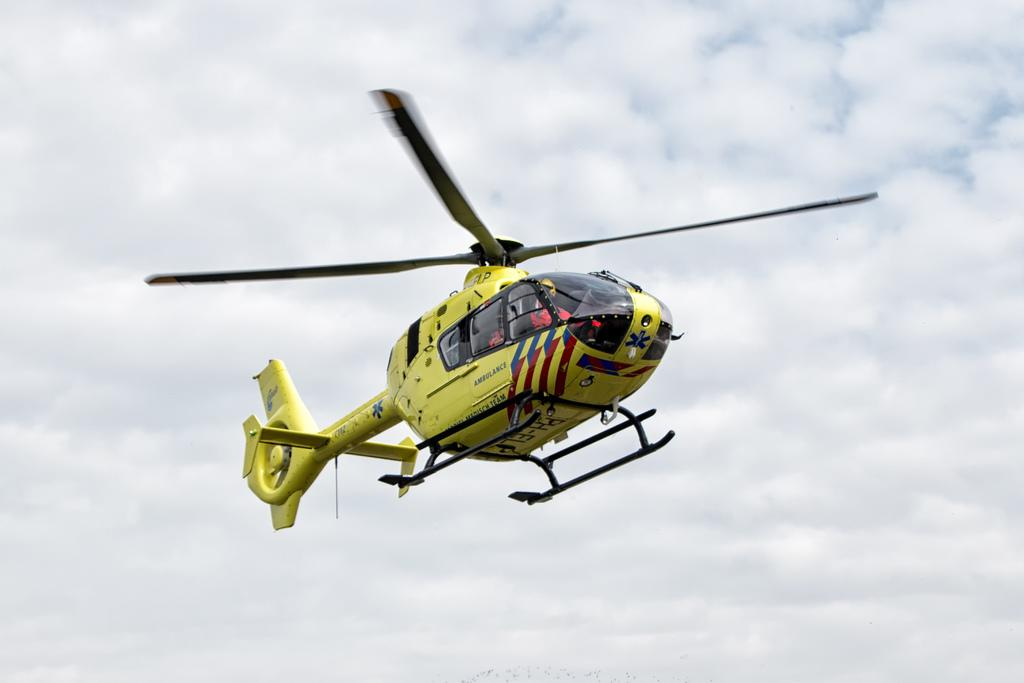What color is the flight in the image? The flight in the image is yellow-colored. What can be seen in the background of the image? The sky is visible in the background of the image. How many tubs are visible in the image? There are no tubs present in the image. What type of slave is depicted in the image? There is no depiction of a slave in the image; it features a yellow-colored flight and the sky. 